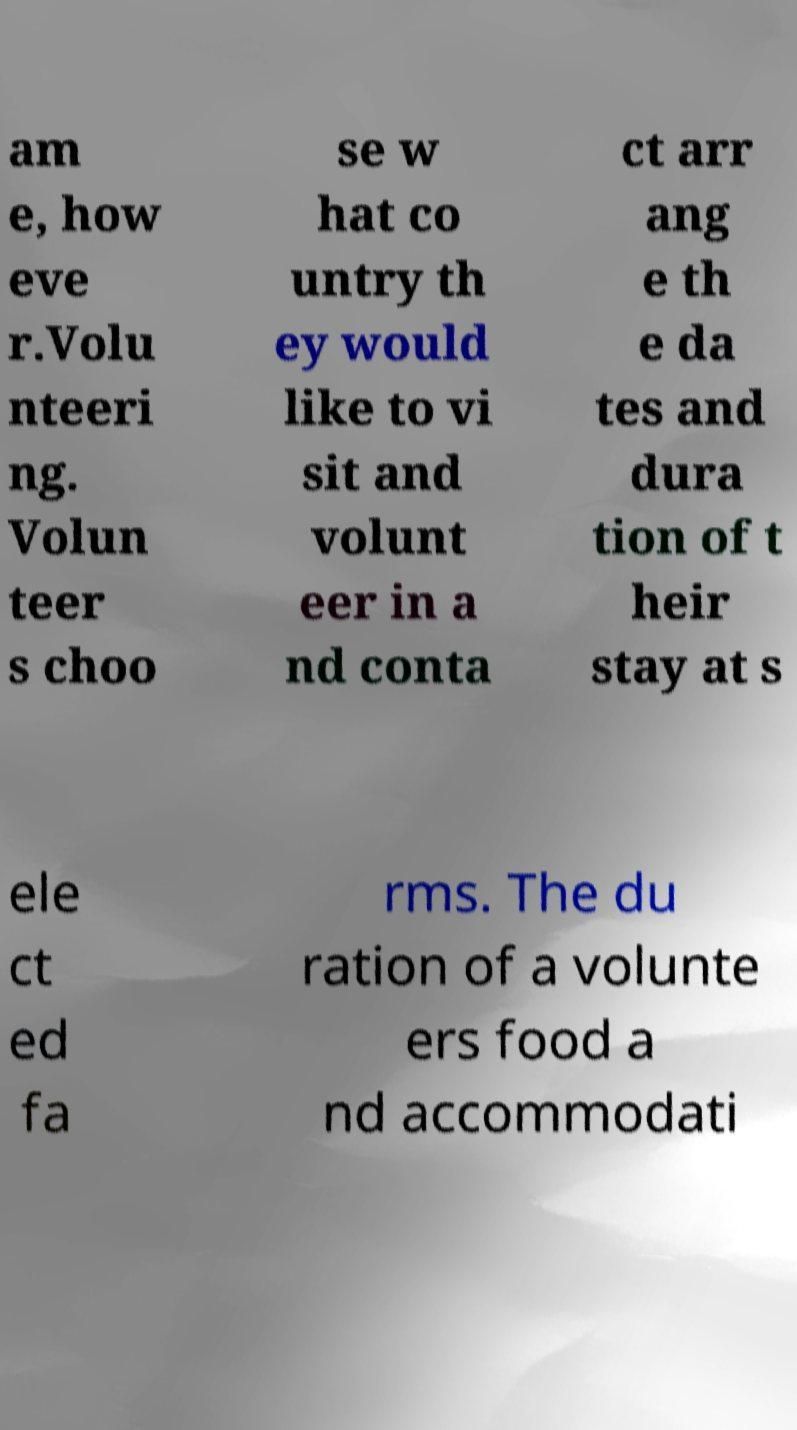What messages or text are displayed in this image? I need them in a readable, typed format. am e, how eve r.Volu nteeri ng. Volun teer s choo se w hat co untry th ey would like to vi sit and volunt eer in a nd conta ct arr ang e th e da tes and dura tion of t heir stay at s ele ct ed fa rms. The du ration of a volunte ers food a nd accommodati 